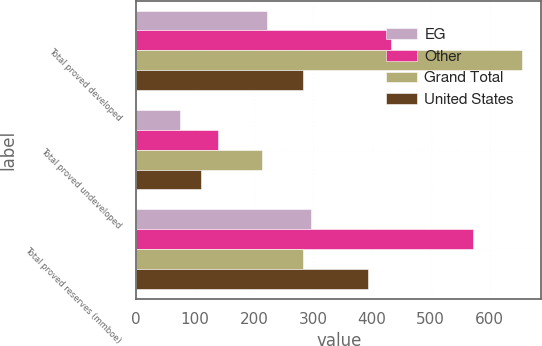<chart> <loc_0><loc_0><loc_500><loc_500><stacked_bar_chart><ecel><fcel>Total proved developed<fcel>Total proved undeveloped<fcel>Total proved reserves (mmboe)<nl><fcel>EG<fcel>222<fcel>75<fcel>297<nl><fcel>Other<fcel>433<fcel>139<fcel>572<nl><fcel>Grand Total<fcel>655<fcel>214<fcel>284<nl><fcel>United States<fcel>284<fcel>110<fcel>394<nl></chart> 